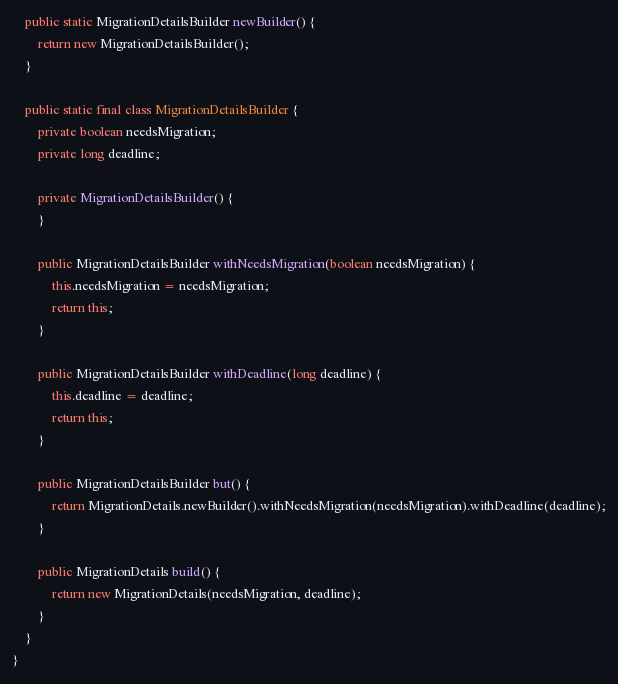Convert code to text. <code><loc_0><loc_0><loc_500><loc_500><_Java_>
    public static MigrationDetailsBuilder newBuilder() {
        return new MigrationDetailsBuilder();
    }

    public static final class MigrationDetailsBuilder {
        private boolean needsMigration;
        private long deadline;

        private MigrationDetailsBuilder() {
        }

        public MigrationDetailsBuilder withNeedsMigration(boolean needsMigration) {
            this.needsMigration = needsMigration;
            return this;
        }

        public MigrationDetailsBuilder withDeadline(long deadline) {
            this.deadline = deadline;
            return this;
        }

        public MigrationDetailsBuilder but() {
            return MigrationDetails.newBuilder().withNeedsMigration(needsMigration).withDeadline(deadline);
        }

        public MigrationDetails build() {
            return new MigrationDetails(needsMigration, deadline);
        }
    }
}
</code> 